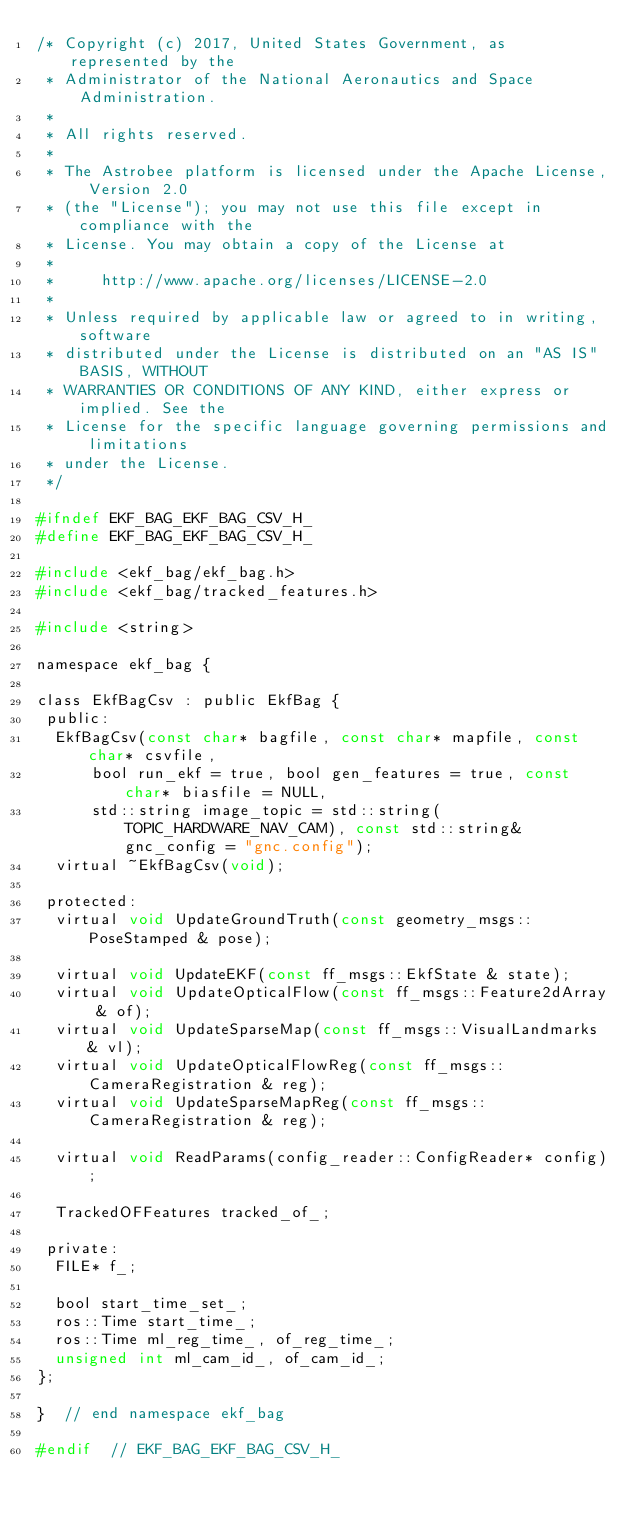<code> <loc_0><loc_0><loc_500><loc_500><_C_>/* Copyright (c) 2017, United States Government, as represented by the
 * Administrator of the National Aeronautics and Space Administration.
 * 
 * All rights reserved.
 * 
 * The Astrobee platform is licensed under the Apache License, Version 2.0
 * (the "License"); you may not use this file except in compliance with the
 * License. You may obtain a copy of the License at
 * 
 *     http://www.apache.org/licenses/LICENSE-2.0
 * 
 * Unless required by applicable law or agreed to in writing, software
 * distributed under the License is distributed on an "AS IS" BASIS, WITHOUT
 * WARRANTIES OR CONDITIONS OF ANY KIND, either express or implied. See the
 * License for the specific language governing permissions and limitations
 * under the License.
 */

#ifndef EKF_BAG_EKF_BAG_CSV_H_
#define EKF_BAG_EKF_BAG_CSV_H_

#include <ekf_bag/ekf_bag.h>
#include <ekf_bag/tracked_features.h>

#include <string>

namespace ekf_bag {

class EkfBagCsv : public EkfBag {
 public:
  EkfBagCsv(const char* bagfile, const char* mapfile, const char* csvfile,
      bool run_ekf = true, bool gen_features = true, const char* biasfile = NULL,
      std::string image_topic = std::string(TOPIC_HARDWARE_NAV_CAM), const std::string& gnc_config = "gnc.config");
  virtual ~EkfBagCsv(void);

 protected:
  virtual void UpdateGroundTruth(const geometry_msgs::PoseStamped & pose);

  virtual void UpdateEKF(const ff_msgs::EkfState & state);
  virtual void UpdateOpticalFlow(const ff_msgs::Feature2dArray & of);
  virtual void UpdateSparseMap(const ff_msgs::VisualLandmarks & vl);
  virtual void UpdateOpticalFlowReg(const ff_msgs::CameraRegistration & reg);
  virtual void UpdateSparseMapReg(const ff_msgs::CameraRegistration & reg);

  virtual void ReadParams(config_reader::ConfigReader* config);

  TrackedOFFeatures tracked_of_;

 private:
  FILE* f_;

  bool start_time_set_;
  ros::Time start_time_;
  ros::Time ml_reg_time_, of_reg_time_;
  unsigned int ml_cam_id_, of_cam_id_;
};

}  // end namespace ekf_bag

#endif  // EKF_BAG_EKF_BAG_CSV_H_

</code> 